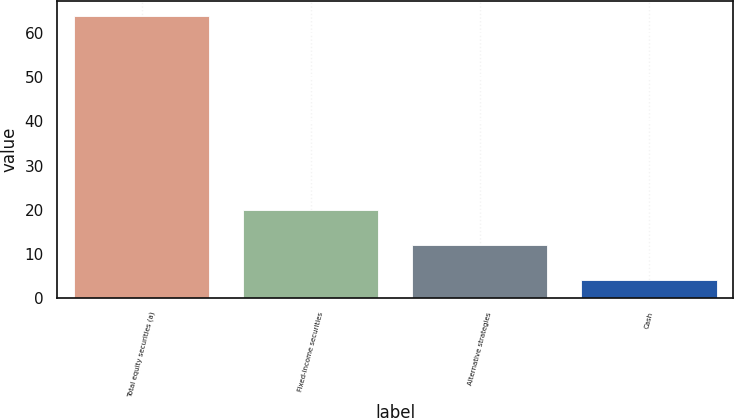Convert chart to OTSL. <chart><loc_0><loc_0><loc_500><loc_500><bar_chart><fcel>Total equity securities (a)<fcel>Fixed-income securities<fcel>Alternative strategies<fcel>Cash<nl><fcel>64<fcel>20<fcel>12<fcel>4<nl></chart> 